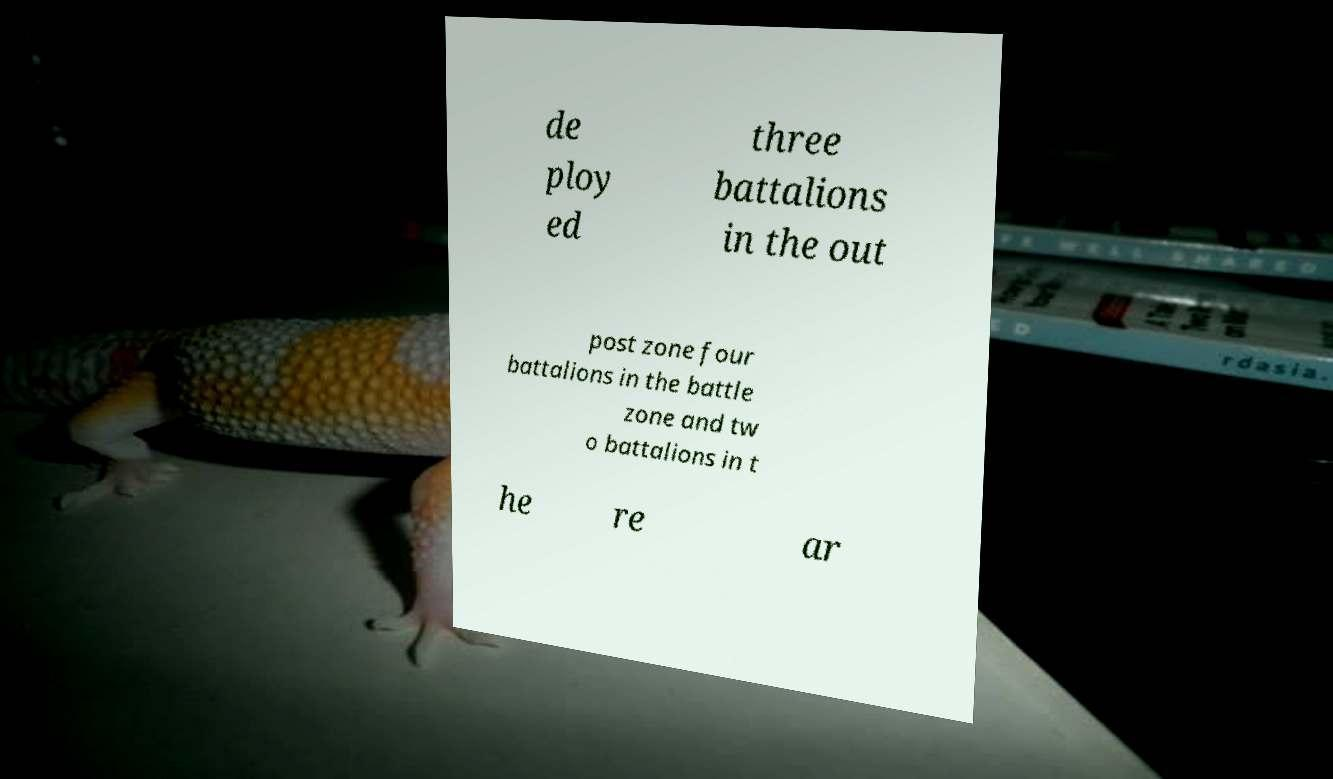There's text embedded in this image that I need extracted. Can you transcribe it verbatim? de ploy ed three battalions in the out post zone four battalions in the battle zone and tw o battalions in t he re ar 